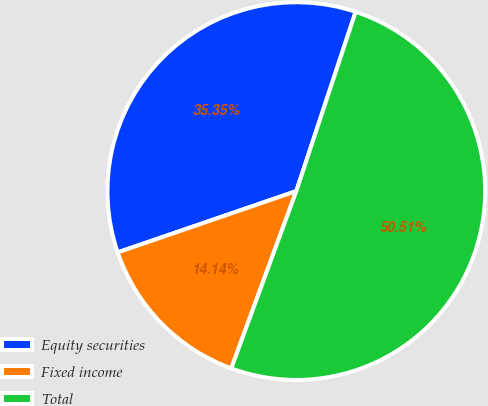Convert chart. <chart><loc_0><loc_0><loc_500><loc_500><pie_chart><fcel>Equity securities<fcel>Fixed income<fcel>Total<nl><fcel>35.35%<fcel>14.14%<fcel>50.51%<nl></chart> 